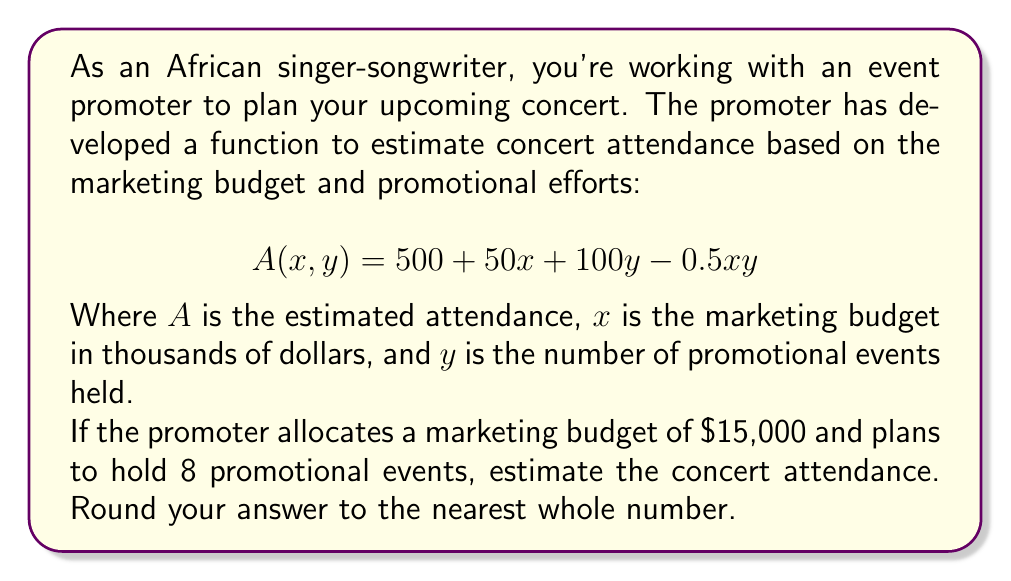Can you solve this math problem? To solve this problem, we need to use the given function and substitute the values for $x$ and $y$:

1. Given function: $A(x, y) = 500 + 50x + 100y - 0.5xy$
2. Marketing budget: $15,000, so $x = 15$ (in thousands of dollars)
3. Number of promotional events: $y = 8$

Let's substitute these values into the function:

$$\begin{align*}
A(15, 8) &= 500 + 50(15) + 100(8) - 0.5(15)(8) \\
&= 500 + 750 + 800 - 60 \\
&= 2050 - 60 \\
&= 1990
\end{align*}$$

The estimated attendance is 1990 people.

Since we're asked to round to the nearest whole number, our final answer remains 1990.
Answer: 1990 people 